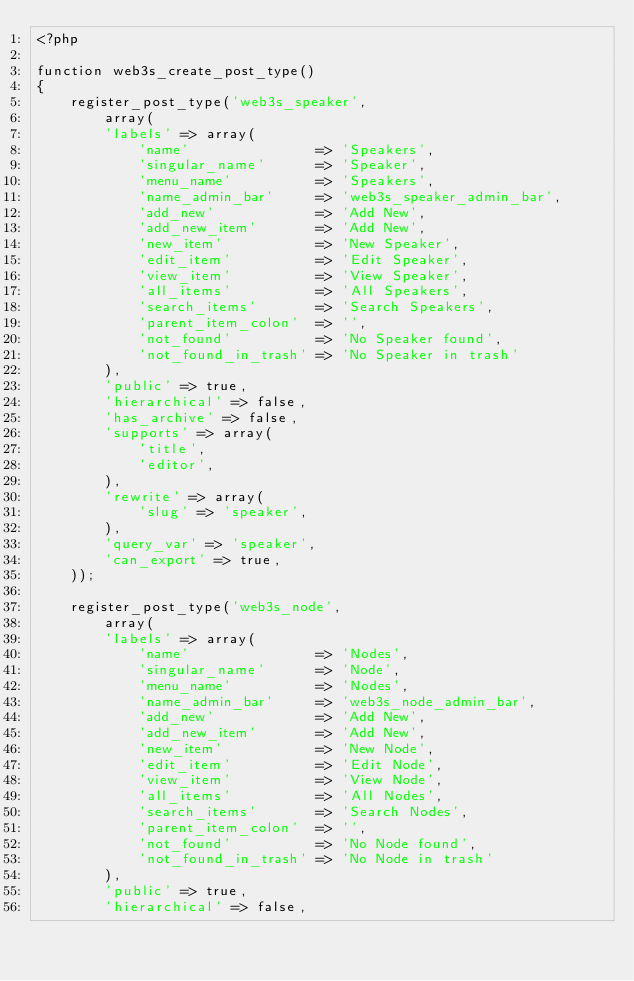Convert code to text. <code><loc_0><loc_0><loc_500><loc_500><_PHP_><?php

function web3s_create_post_type()
{
    register_post_type('web3s_speaker',
        array(
        'labels' => array(
            'name'               => 'Speakers',
            'singular_name'      => 'Speaker',
            'menu_name'          => 'Speakers',
            'name_admin_bar'     => 'web3s_speaker_admin_bar',
            'add_new'            => 'Add New',
            'add_new_item'       => 'Add New',
            'new_item'           => 'New Speaker',
            'edit_item'          => 'Edit Speaker',
            'view_item'          => 'View Speaker',
            'all_items'          => 'All Speakers',
            'search_items'       => 'Search Speakers',
            'parent_item_colon'  => '',
            'not_found'          => 'No Speaker found',
            'not_found_in_trash' => 'No Speaker in trash'
        ),
        'public' => true,
        'hierarchical' => false,
        'has_archive' => false,
        'supports' => array(
            'title',
            'editor',
        ),
        'rewrite' => array(
            'slug' => 'speaker',
        ),
        'query_var' => 'speaker',
        'can_export' => true,
    ));

    register_post_type('web3s_node',
        array(
        'labels' => array(
            'name'               => 'Nodes',
            'singular_name'      => 'Node',
            'menu_name'          => 'Nodes',
            'name_admin_bar'     => 'web3s_node_admin_bar',
            'add_new'            => 'Add New',
            'add_new_item'       => 'Add New',
            'new_item'           => 'New Node',
            'edit_item'          => 'Edit Node',
            'view_item'          => 'View Node',
            'all_items'          => 'All Nodes',
            'search_items'       => 'Search Nodes',
            'parent_item_colon'  => '',
            'not_found'          => 'No Node found',
            'not_found_in_trash' => 'No Node in trash'
        ),
        'public' => true,
        'hierarchical' => false,</code> 